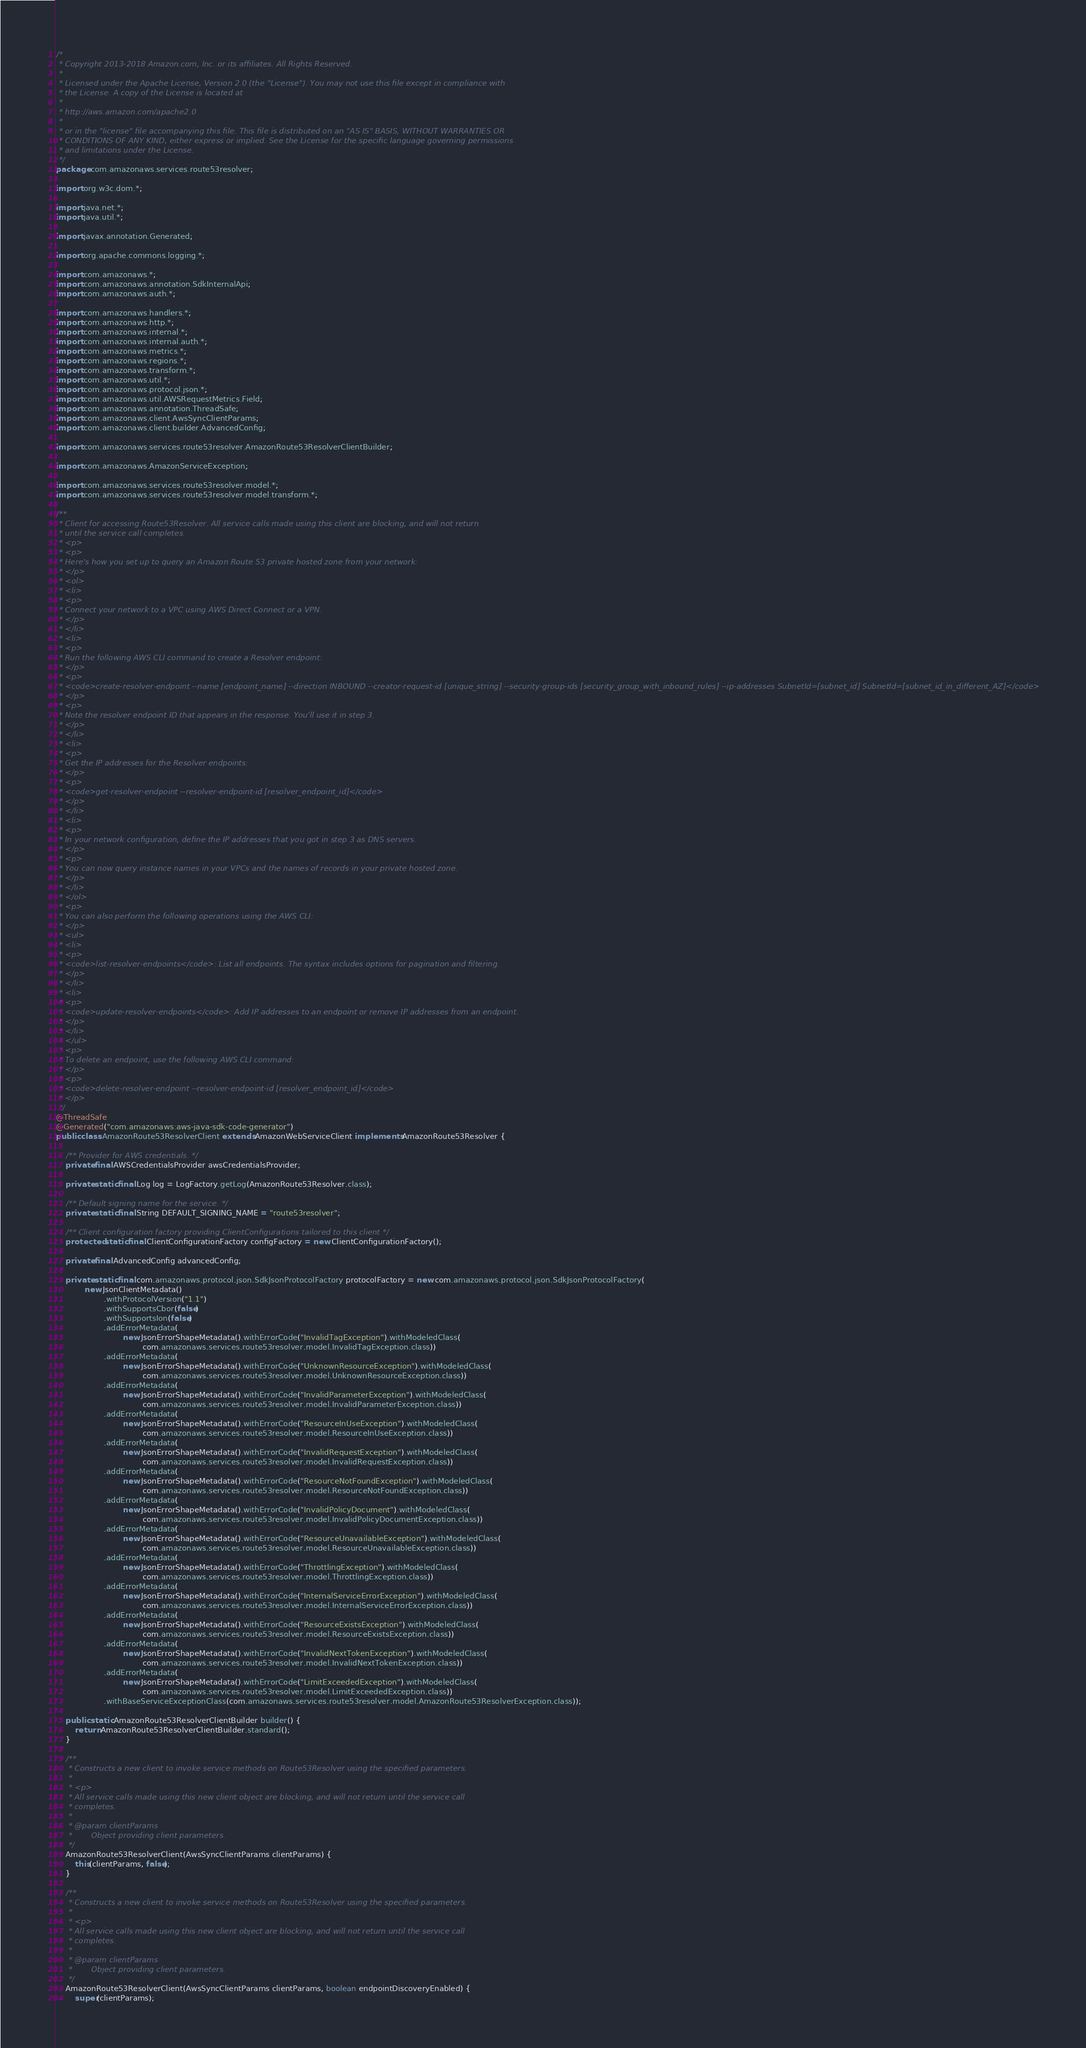<code> <loc_0><loc_0><loc_500><loc_500><_Java_>/*
 * Copyright 2013-2018 Amazon.com, Inc. or its affiliates. All Rights Reserved.
 * 
 * Licensed under the Apache License, Version 2.0 (the "License"). You may not use this file except in compliance with
 * the License. A copy of the License is located at
 * 
 * http://aws.amazon.com/apache2.0
 * 
 * or in the "license" file accompanying this file. This file is distributed on an "AS IS" BASIS, WITHOUT WARRANTIES OR
 * CONDITIONS OF ANY KIND, either express or implied. See the License for the specific language governing permissions
 * and limitations under the License.
 */
package com.amazonaws.services.route53resolver;

import org.w3c.dom.*;

import java.net.*;
import java.util.*;

import javax.annotation.Generated;

import org.apache.commons.logging.*;

import com.amazonaws.*;
import com.amazonaws.annotation.SdkInternalApi;
import com.amazonaws.auth.*;

import com.amazonaws.handlers.*;
import com.amazonaws.http.*;
import com.amazonaws.internal.*;
import com.amazonaws.internal.auth.*;
import com.amazonaws.metrics.*;
import com.amazonaws.regions.*;
import com.amazonaws.transform.*;
import com.amazonaws.util.*;
import com.amazonaws.protocol.json.*;
import com.amazonaws.util.AWSRequestMetrics.Field;
import com.amazonaws.annotation.ThreadSafe;
import com.amazonaws.client.AwsSyncClientParams;
import com.amazonaws.client.builder.AdvancedConfig;

import com.amazonaws.services.route53resolver.AmazonRoute53ResolverClientBuilder;

import com.amazonaws.AmazonServiceException;

import com.amazonaws.services.route53resolver.model.*;
import com.amazonaws.services.route53resolver.model.transform.*;

/**
 * Client for accessing Route53Resolver. All service calls made using this client are blocking, and will not return
 * until the service call completes.
 * <p>
 * <p>
 * Here's how you set up to query an Amazon Route 53 private hosted zone from your network:
 * </p>
 * <ol>
 * <li>
 * <p>
 * Connect your network to a VPC using AWS Direct Connect or a VPN.
 * </p>
 * </li>
 * <li>
 * <p>
 * Run the following AWS CLI command to create a Resolver endpoint:
 * </p>
 * <p>
 * <code>create-resolver-endpoint --name [endpoint_name] --direction INBOUND --creator-request-id [unique_string] --security-group-ids [security_group_with_inbound_rules] --ip-addresses SubnetId=[subnet_id] SubnetId=[subnet_id_in_different_AZ]</code>
 * </p>
 * <p>
 * Note the resolver endpoint ID that appears in the response. You'll use it in step 3.
 * </p>
 * </li>
 * <li>
 * <p>
 * Get the IP addresses for the Resolver endpoints:
 * </p>
 * <p>
 * <code>get-resolver-endpoint --resolver-endpoint-id [resolver_endpoint_id]</code>
 * </p>
 * </li>
 * <li>
 * <p>
 * In your network configuration, define the IP addresses that you got in step 3 as DNS servers.
 * </p>
 * <p>
 * You can now query instance names in your VPCs and the names of records in your private hosted zone.
 * </p>
 * </li>
 * </ol>
 * <p>
 * You can also perform the following operations using the AWS CLI:
 * </p>
 * <ul>
 * <li>
 * <p>
 * <code>list-resolver-endpoints</code>: List all endpoints. The syntax includes options for pagination and filtering.
 * </p>
 * </li>
 * <li>
 * <p>
 * <code>update-resolver-endpoints</code>: Add IP addresses to an endpoint or remove IP addresses from an endpoint.
 * </p>
 * </li>
 * </ul>
 * <p>
 * To delete an endpoint, use the following AWS CLI command:
 * </p>
 * <p>
 * <code>delete-resolver-endpoint --resolver-endpoint-id [resolver_endpoint_id]</code>
 * </p>
 */
@ThreadSafe
@Generated("com.amazonaws:aws-java-sdk-code-generator")
public class AmazonRoute53ResolverClient extends AmazonWebServiceClient implements AmazonRoute53Resolver {

    /** Provider for AWS credentials. */
    private final AWSCredentialsProvider awsCredentialsProvider;

    private static final Log log = LogFactory.getLog(AmazonRoute53Resolver.class);

    /** Default signing name for the service. */
    private static final String DEFAULT_SIGNING_NAME = "route53resolver";

    /** Client configuration factory providing ClientConfigurations tailored to this client */
    protected static final ClientConfigurationFactory configFactory = new ClientConfigurationFactory();

    private final AdvancedConfig advancedConfig;

    private static final com.amazonaws.protocol.json.SdkJsonProtocolFactory protocolFactory = new com.amazonaws.protocol.json.SdkJsonProtocolFactory(
            new JsonClientMetadata()
                    .withProtocolVersion("1.1")
                    .withSupportsCbor(false)
                    .withSupportsIon(false)
                    .addErrorMetadata(
                            new JsonErrorShapeMetadata().withErrorCode("InvalidTagException").withModeledClass(
                                    com.amazonaws.services.route53resolver.model.InvalidTagException.class))
                    .addErrorMetadata(
                            new JsonErrorShapeMetadata().withErrorCode("UnknownResourceException").withModeledClass(
                                    com.amazonaws.services.route53resolver.model.UnknownResourceException.class))
                    .addErrorMetadata(
                            new JsonErrorShapeMetadata().withErrorCode("InvalidParameterException").withModeledClass(
                                    com.amazonaws.services.route53resolver.model.InvalidParameterException.class))
                    .addErrorMetadata(
                            new JsonErrorShapeMetadata().withErrorCode("ResourceInUseException").withModeledClass(
                                    com.amazonaws.services.route53resolver.model.ResourceInUseException.class))
                    .addErrorMetadata(
                            new JsonErrorShapeMetadata().withErrorCode("InvalidRequestException").withModeledClass(
                                    com.amazonaws.services.route53resolver.model.InvalidRequestException.class))
                    .addErrorMetadata(
                            new JsonErrorShapeMetadata().withErrorCode("ResourceNotFoundException").withModeledClass(
                                    com.amazonaws.services.route53resolver.model.ResourceNotFoundException.class))
                    .addErrorMetadata(
                            new JsonErrorShapeMetadata().withErrorCode("InvalidPolicyDocument").withModeledClass(
                                    com.amazonaws.services.route53resolver.model.InvalidPolicyDocumentException.class))
                    .addErrorMetadata(
                            new JsonErrorShapeMetadata().withErrorCode("ResourceUnavailableException").withModeledClass(
                                    com.amazonaws.services.route53resolver.model.ResourceUnavailableException.class))
                    .addErrorMetadata(
                            new JsonErrorShapeMetadata().withErrorCode("ThrottlingException").withModeledClass(
                                    com.amazonaws.services.route53resolver.model.ThrottlingException.class))
                    .addErrorMetadata(
                            new JsonErrorShapeMetadata().withErrorCode("InternalServiceErrorException").withModeledClass(
                                    com.amazonaws.services.route53resolver.model.InternalServiceErrorException.class))
                    .addErrorMetadata(
                            new JsonErrorShapeMetadata().withErrorCode("ResourceExistsException").withModeledClass(
                                    com.amazonaws.services.route53resolver.model.ResourceExistsException.class))
                    .addErrorMetadata(
                            new JsonErrorShapeMetadata().withErrorCode("InvalidNextTokenException").withModeledClass(
                                    com.amazonaws.services.route53resolver.model.InvalidNextTokenException.class))
                    .addErrorMetadata(
                            new JsonErrorShapeMetadata().withErrorCode("LimitExceededException").withModeledClass(
                                    com.amazonaws.services.route53resolver.model.LimitExceededException.class))
                    .withBaseServiceExceptionClass(com.amazonaws.services.route53resolver.model.AmazonRoute53ResolverException.class));

    public static AmazonRoute53ResolverClientBuilder builder() {
        return AmazonRoute53ResolverClientBuilder.standard();
    }

    /**
     * Constructs a new client to invoke service methods on Route53Resolver using the specified parameters.
     *
     * <p>
     * All service calls made using this new client object are blocking, and will not return until the service call
     * completes.
     *
     * @param clientParams
     *        Object providing client parameters.
     */
    AmazonRoute53ResolverClient(AwsSyncClientParams clientParams) {
        this(clientParams, false);
    }

    /**
     * Constructs a new client to invoke service methods on Route53Resolver using the specified parameters.
     *
     * <p>
     * All service calls made using this new client object are blocking, and will not return until the service call
     * completes.
     *
     * @param clientParams
     *        Object providing client parameters.
     */
    AmazonRoute53ResolverClient(AwsSyncClientParams clientParams, boolean endpointDiscoveryEnabled) {
        super(clientParams);</code> 